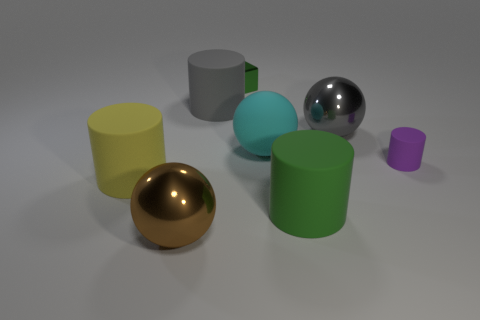Are there the same number of big green matte things that are right of the big gray ball and big brown things?
Your answer should be very brief. No. What is the shape of the metallic object that is both behind the small rubber cylinder and left of the large green object?
Offer a very short reply. Cube. The tiny thing that is the same shape as the large yellow rubber object is what color?
Offer a very short reply. Purple. Are there any other things that have the same color as the cube?
Provide a short and direct response. Yes. The matte object to the left of the large cylinder behind the purple rubber object that is behind the brown sphere is what shape?
Provide a succinct answer. Cylinder. Do the green rubber cylinder that is right of the gray matte cylinder and the gray object that is left of the rubber sphere have the same size?
Keep it short and to the point. Yes. What number of large things have the same material as the gray cylinder?
Make the answer very short. 3. How many big rubber objects are on the right side of the gray thing that is on the left side of the big gray thing right of the big green cylinder?
Offer a terse response. 2. Is the large brown object the same shape as the large yellow object?
Your answer should be very brief. No. Are there any big gray rubber objects of the same shape as the big green matte object?
Ensure brevity in your answer.  Yes. 